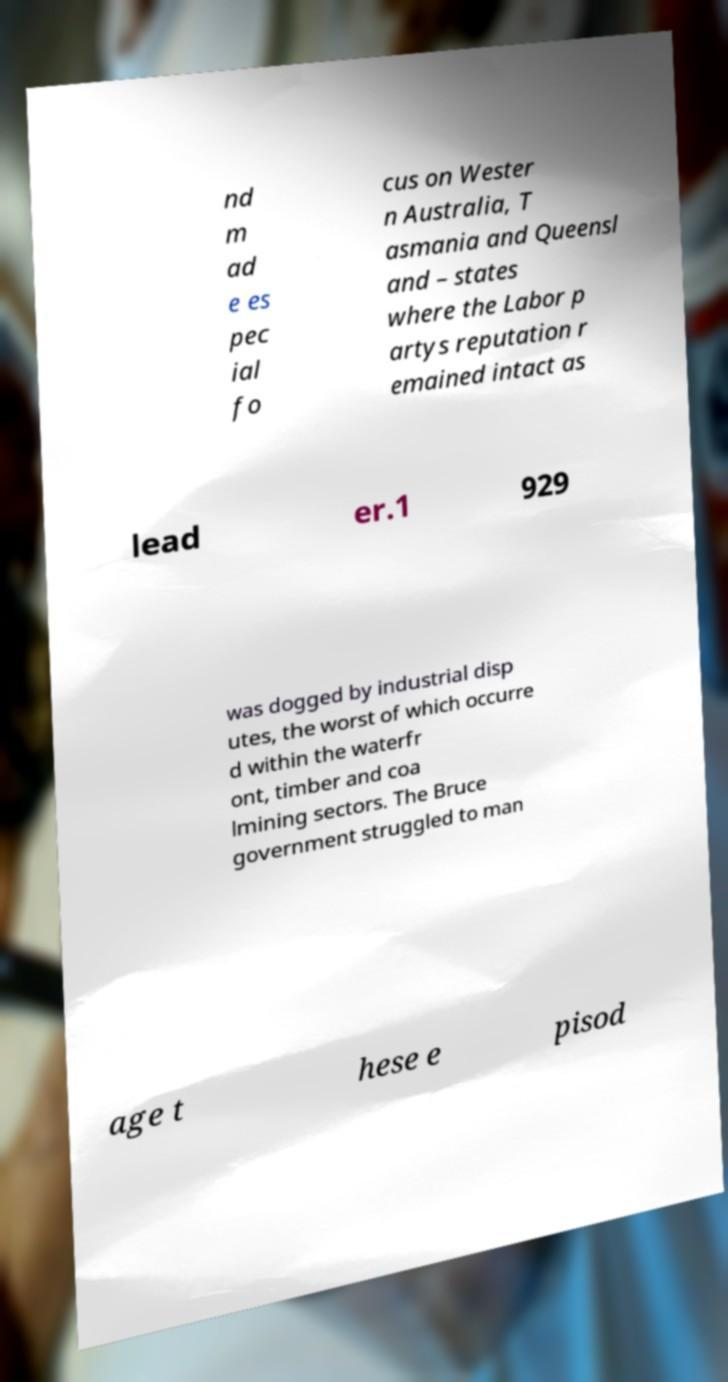Please identify and transcribe the text found in this image. nd m ad e es pec ial fo cus on Wester n Australia, T asmania and Queensl and – states where the Labor p artys reputation r emained intact as lead er.1 929 was dogged by industrial disp utes, the worst of which occurre d within the waterfr ont, timber and coa lmining sectors. The Bruce government struggled to man age t hese e pisod 